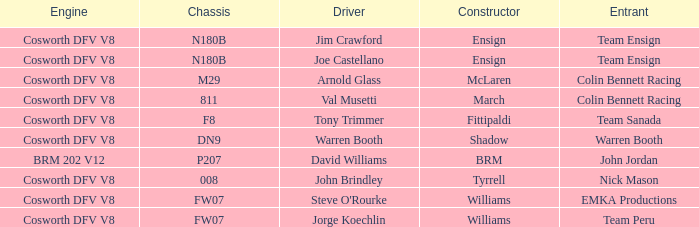What engine is used by Colin Bennett Racing with an 811 chassis? Cosworth DFV V8. 